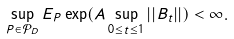Convert formula to latex. <formula><loc_0><loc_0><loc_500><loc_500>\sup _ { P \in \mathcal { P } _ { D } } E _ { P } \exp ( A \sup _ { 0 \leq t \leq 1 } | | B _ { t } | | ) < \infty .</formula> 